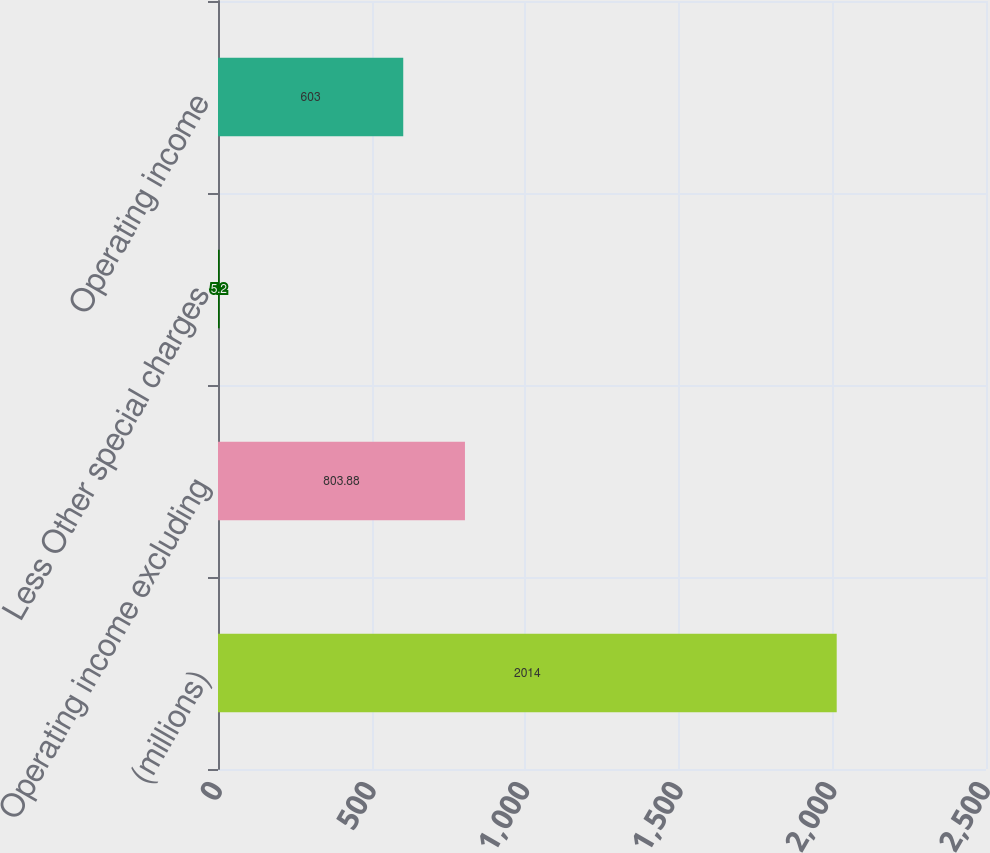Convert chart to OTSL. <chart><loc_0><loc_0><loc_500><loc_500><bar_chart><fcel>(millions)<fcel>Operating income excluding<fcel>Less Other special charges<fcel>Operating income<nl><fcel>2014<fcel>803.88<fcel>5.2<fcel>603<nl></chart> 